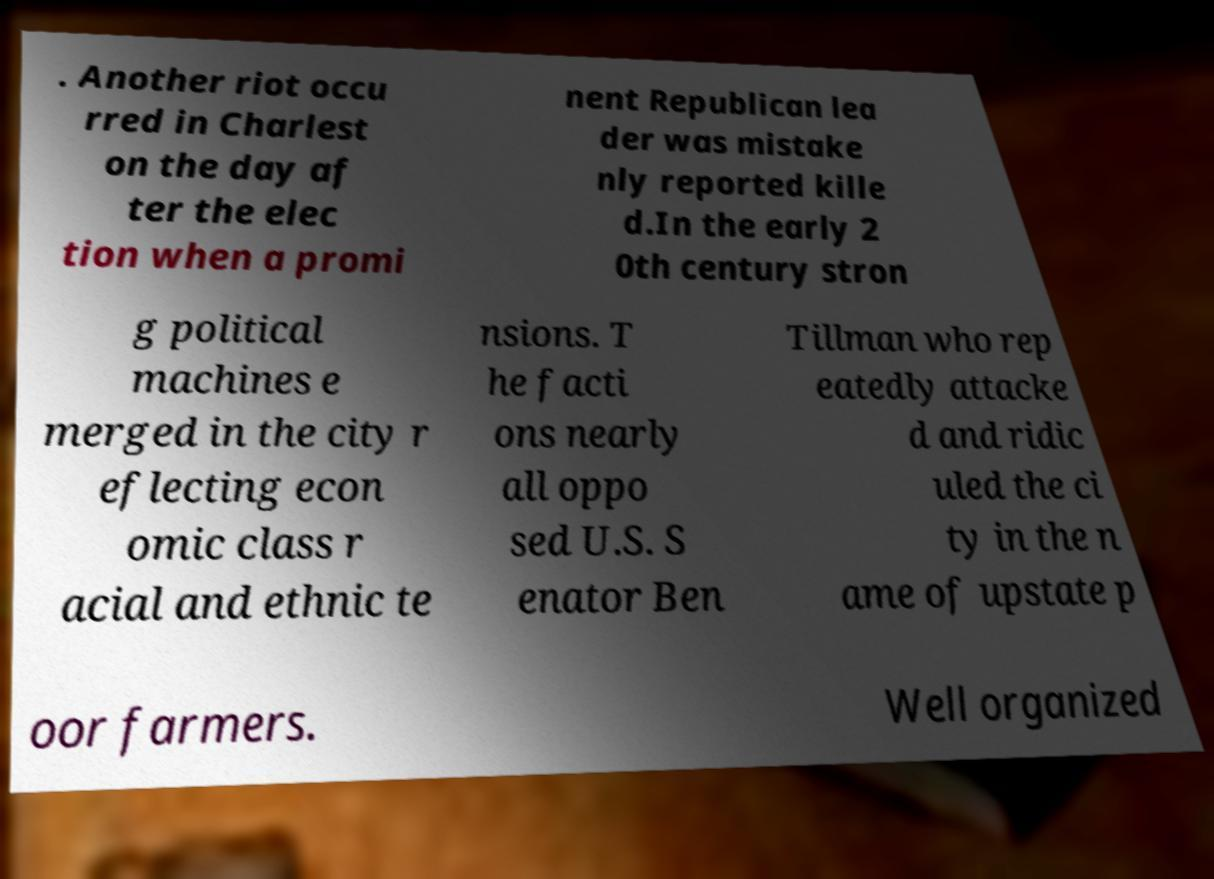Please identify and transcribe the text found in this image. . Another riot occu rred in Charlest on the day af ter the elec tion when a promi nent Republican lea der was mistake nly reported kille d.In the early 2 0th century stron g political machines e merged in the city r eflecting econ omic class r acial and ethnic te nsions. T he facti ons nearly all oppo sed U.S. S enator Ben Tillman who rep eatedly attacke d and ridic uled the ci ty in the n ame of upstate p oor farmers. Well organized 